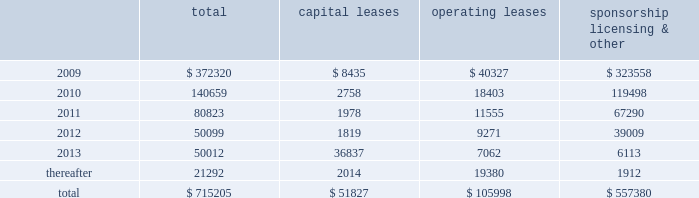Mastercard incorporated notes to consolidated financial statements 2014 ( continued ) ( in thousands , except percent and per share data ) note 17 .
Commitments at december 31 , 2008 , the company had the following future minimum payments due under non-cancelable agreements : capital leases operating leases sponsorship , licensing & .
Included in the table above are capital leases with imputed interest expense of $ 9483 and a net present value of minimum lease payments of $ 42343 .
In addition , at december 31 , 2008 , $ 92300 of the future minimum payments in the table above for leases , sponsorship , licensing and other agreements was accrued .
Consolidated rental expense for the company 2019s office space , which is recognized on a straight line basis over the life of the lease , was approximately $ 42905 , $ 35614 and $ 31467 for the years ended december 31 , 2008 , 2007 and 2006 , respectively .
Consolidated lease expense for automobiles , computer equipment and office equipment was $ 7694 , $ 7679 and $ 8419 for the years ended december 31 , 2008 , 2007 and 2006 , respectively .
In january 2003 , mastercard purchased a building in kansas city , missouri for approximately $ 23572 .
The building is a co-processing data center which replaced a back-up data center in lake success , new york .
During 2003 , mastercard entered into agreements with the city of kansas city for ( i ) the sale-leaseback of the building and related equipment which totaled $ 36382 and ( ii ) the purchase of municipal bonds for the same amount which have been classified as municipal bonds held-to-maturity .
The agreements enabled mastercard to secure state and local financial benefits .
No gain or loss was recorded in connection with the agreements .
The leaseback has been accounted for as a capital lease as the agreement contains a bargain purchase option at the end of the ten-year lease term on april 1 , 2013 .
The building and related equipment are being depreciated over their estimated economic life in accordance with the company 2019s policy .
Rent of $ 1819 is due annually and is equal to the interest due on the municipal bonds .
The future minimum lease payments are $ 45781 and are included in the table above .
A portion of the building was subleased to the original building owner for a five-year term with a renewal option .
As of december 31 , 2008 , the future minimum sublease rental income is $ 4416 .
Note 18 .
Obligations under litigation settlements on october 27 , 2008 , mastercard and visa inc .
( 201cvisa 201d ) entered into a settlement agreement ( the 201cdiscover settlement 201d ) with discover financial services , inc .
( 201cdiscover 201d ) relating to the u.s .
Federal antitrust litigation amongst the parties .
The discover settlement ended all litigation between the parties for a total of $ 2750000 .
In july 2008 , mastercard and visa had entered into a judgment sharing agreement that allocated responsibility for any judgment or settlement of the discover action between the parties .
Accordingly , the mastercard share of the discover settlement was $ 862500 , which was paid to discover in november 2008 .
In addition , in connection with the discover settlement , morgan stanley , discover 2019s former parent company , paid mastercard $ 35000 in november 2008 , pursuant to a separate agreement .
The net impact of $ 827500 is included in litigation settlements for the year ended december 31 , 2008. .
In 2009 what was the percent of the operating lease to the total? 
Computations: (40327 / 372320)
Answer: 0.10831. 